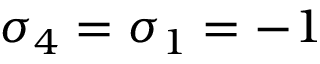<formula> <loc_0><loc_0><loc_500><loc_500>\sigma _ { 4 } = \sigma _ { 1 } = - 1</formula> 